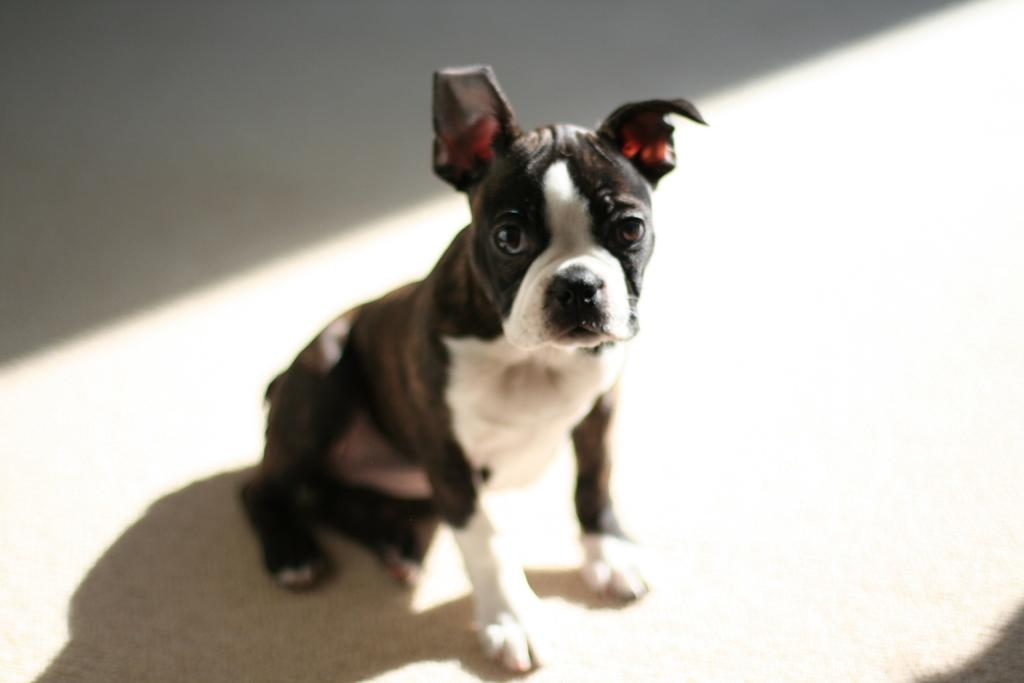What animal can be seen in the picture? There is a dog in the picture. What is the dog doing in the picture? The dog is sitting on the floor. What color is the floor in the picture? The floor is white in color. Can you describe the appearance of the dog? The dog is black and has some white color on its body. Where is the faucet located in the picture? There is no faucet present in the image. How many oranges are on the floor next to the dog? There are no oranges present in the image. 